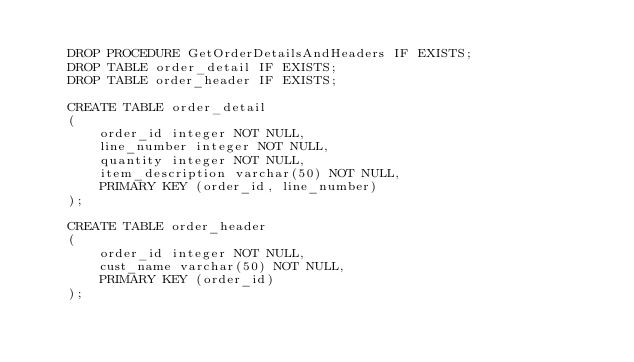<code> <loc_0><loc_0><loc_500><loc_500><_SQL_>
    DROP PROCEDURE GetOrderDetailsAndHeaders IF EXISTS;
    DROP TABLE order_detail IF EXISTS;
    DROP TABLE order_header IF EXISTS;

    CREATE TABLE order_detail
    (
        order_id integer NOT NULL,
        line_number integer NOT NULL,
        quantity integer NOT NULL,
        item_description varchar(50) NOT NULL,
        PRIMARY KEY (order_id, line_number)
    );

    CREATE TABLE order_header
    (
        order_id integer NOT NULL,
        cust_name varchar(50) NOT NULL,
        PRIMARY KEY (order_id)
    );
</code> 